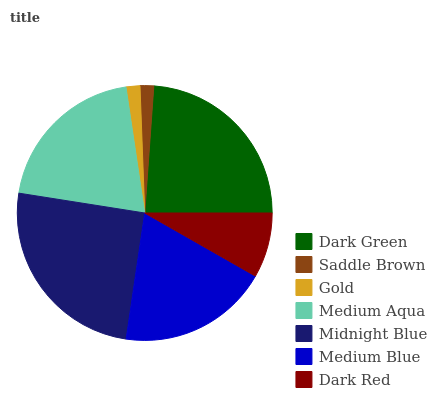Is Saddle Brown the minimum?
Answer yes or no. Yes. Is Midnight Blue the maximum?
Answer yes or no. Yes. Is Gold the minimum?
Answer yes or no. No. Is Gold the maximum?
Answer yes or no. No. Is Gold greater than Saddle Brown?
Answer yes or no. Yes. Is Saddle Brown less than Gold?
Answer yes or no. Yes. Is Saddle Brown greater than Gold?
Answer yes or no. No. Is Gold less than Saddle Brown?
Answer yes or no. No. Is Medium Blue the high median?
Answer yes or no. Yes. Is Medium Blue the low median?
Answer yes or no. Yes. Is Dark Green the high median?
Answer yes or no. No. Is Saddle Brown the low median?
Answer yes or no. No. 